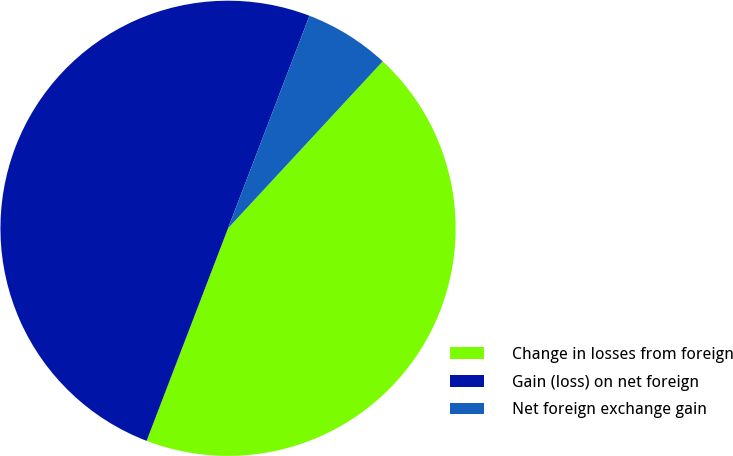Convert chart to OTSL. <chart><loc_0><loc_0><loc_500><loc_500><pie_chart><fcel>Change in losses from foreign<fcel>Gain (loss) on net foreign<fcel>Net foreign exchange gain<nl><fcel>43.93%<fcel>50.0%<fcel>6.07%<nl></chart> 